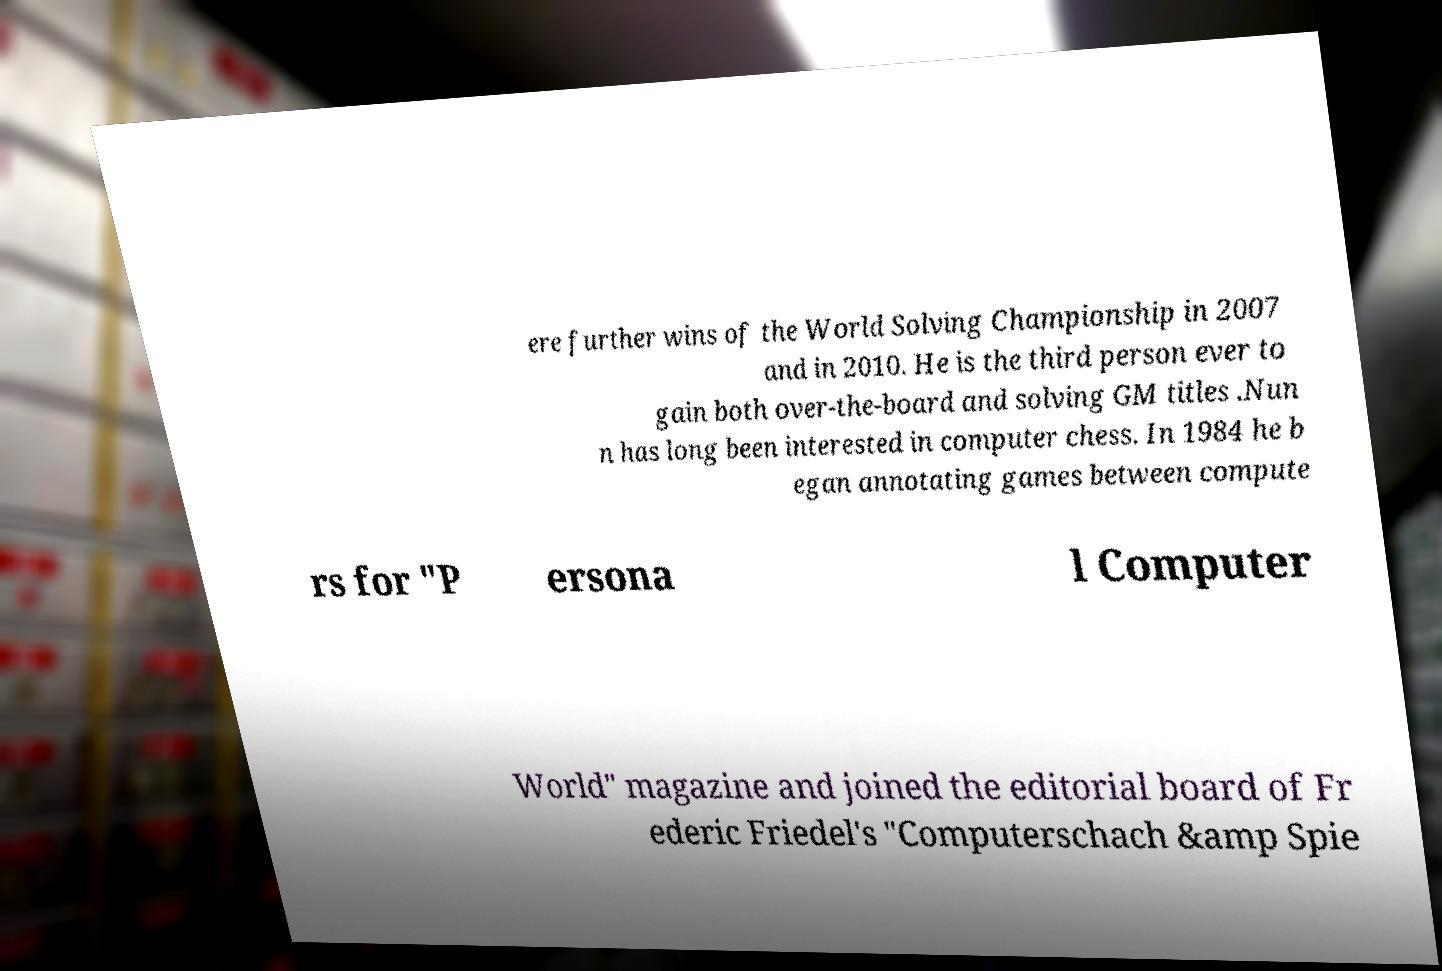Can you accurately transcribe the text from the provided image for me? ere further wins of the World Solving Championship in 2007 and in 2010. He is the third person ever to gain both over-the-board and solving GM titles .Nun n has long been interested in computer chess. In 1984 he b egan annotating games between compute rs for "P ersona l Computer World" magazine and joined the editorial board of Fr ederic Friedel's "Computerschach &amp Spie 